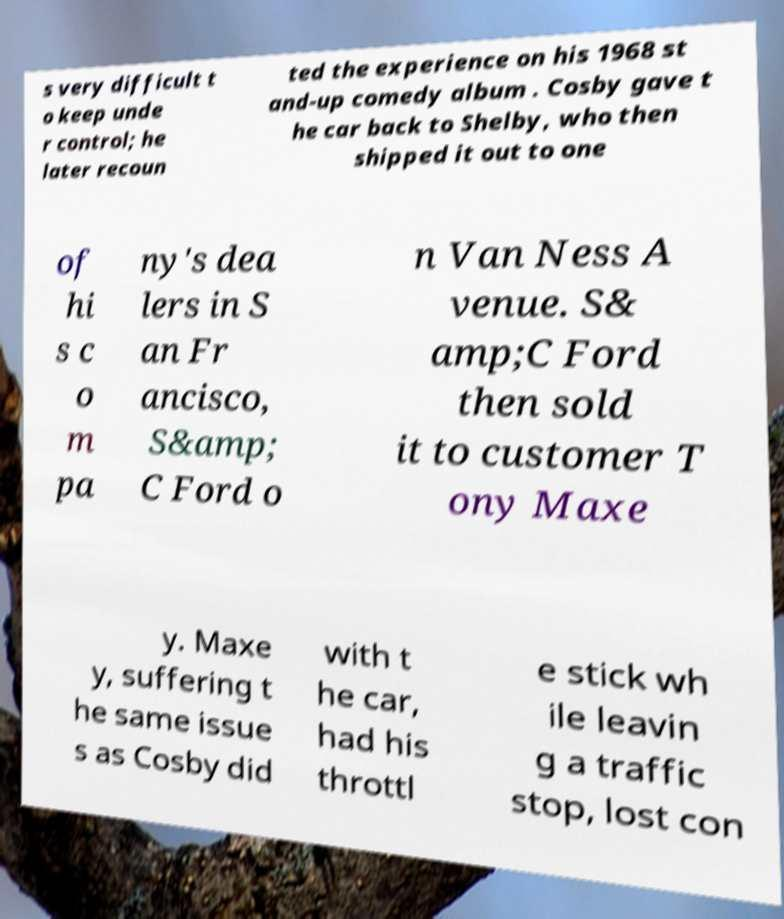There's text embedded in this image that I need extracted. Can you transcribe it verbatim? s very difficult t o keep unde r control; he later recoun ted the experience on his 1968 st and-up comedy album . Cosby gave t he car back to Shelby, who then shipped it out to one of hi s c o m pa ny's dea lers in S an Fr ancisco, S&amp; C Ford o n Van Ness A venue. S& amp;C Ford then sold it to customer T ony Maxe y. Maxe y, suffering t he same issue s as Cosby did with t he car, had his throttl e stick wh ile leavin g a traffic stop, lost con 